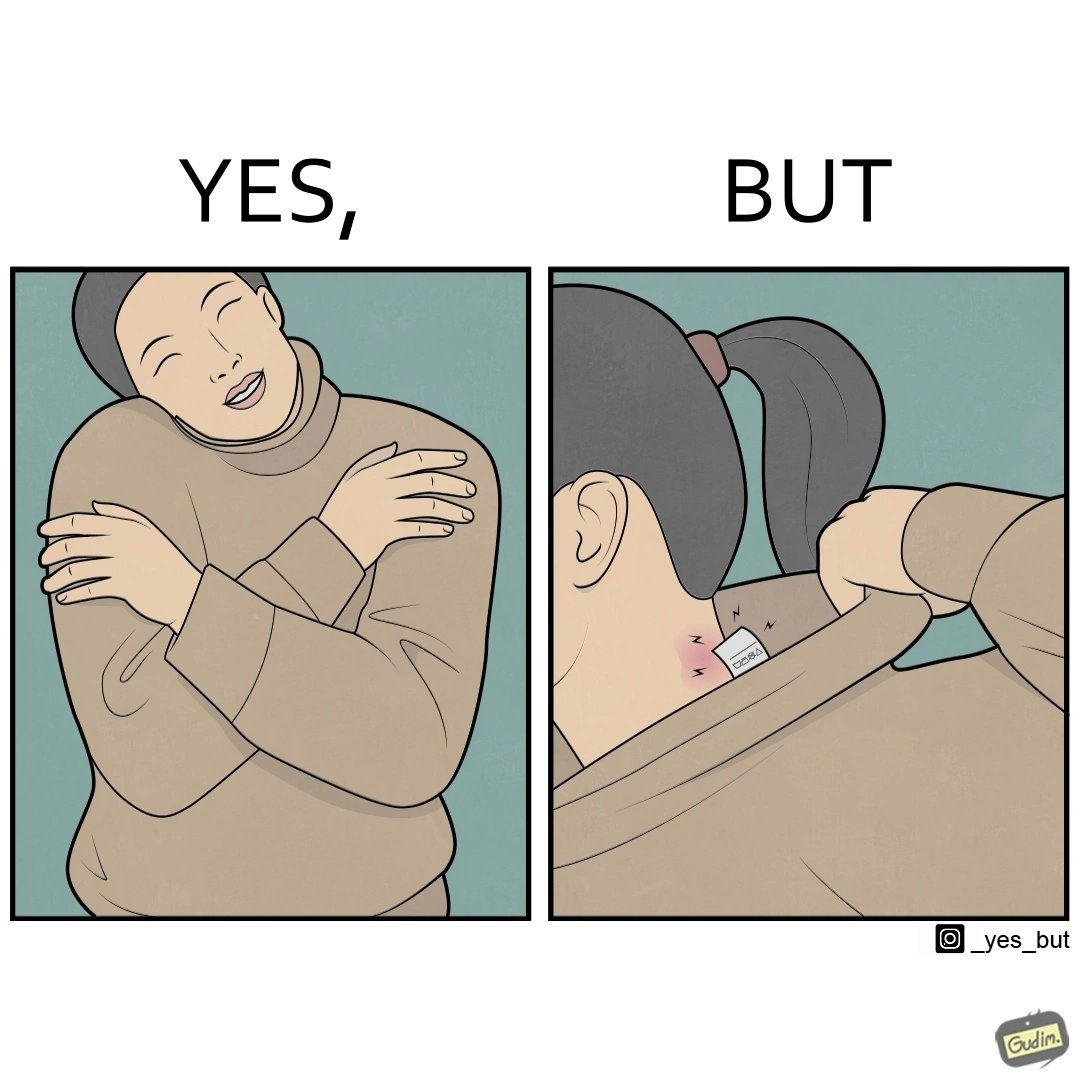What is shown in the left half versus the right half of this image? In the left part of the image: It is a woman enjoying the warmth and comfort of her sweater In the right part of the image: It a womans neck, irritated and red due to manufacturers tags on her clothes 